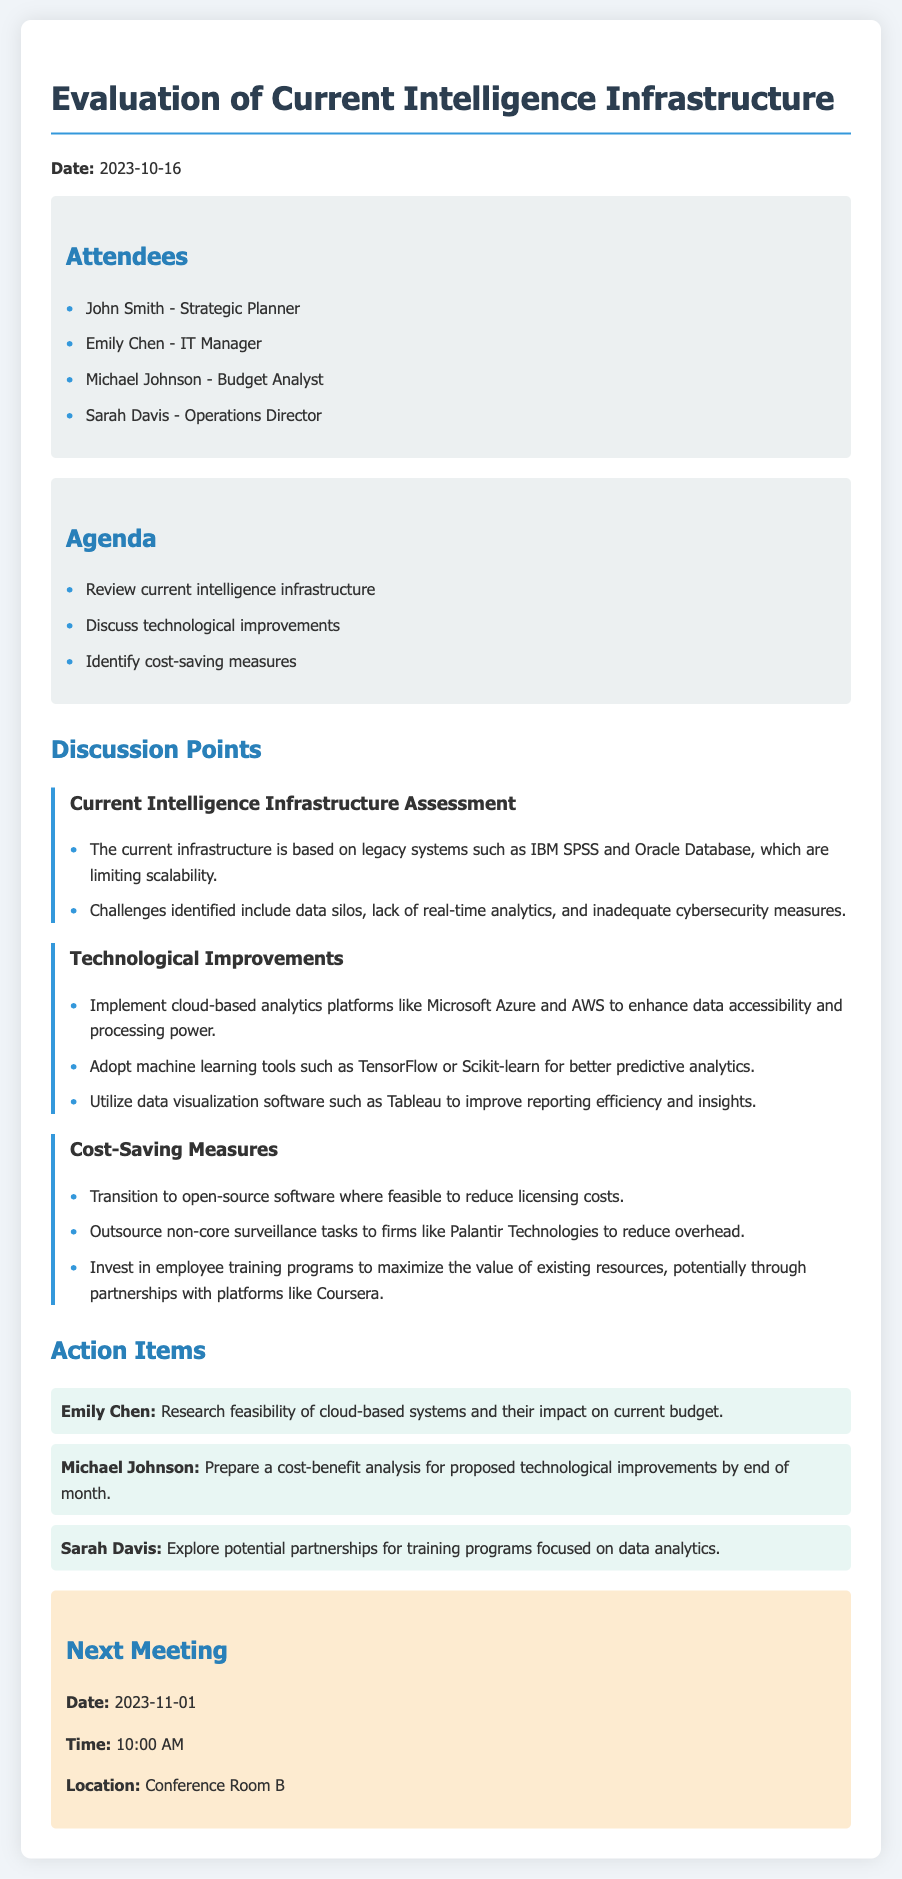What is the date of the meeting? The date of the meeting is specified at the beginning of the document as "2023-10-16".
Answer: 2023-10-16 Who is the IT Manager? The IT Manager is listed among the attendees of the meeting.
Answer: Emily Chen What is the agenda item related to technological improvements? The agenda includes discussing technological improvements as one of its points.
Answer: Discuss technological improvements What software is suggested for data visualization? The document mentions specific software that can be utilized for data visualization.
Answer: Tableau What is one of the identified challenges with the current infrastructure? Challenges are outlined in the current intelligence infrastructure assessment section of the document.
Answer: Data silos What is the action item assigned to Michael Johnson? The action items include tasks assigned to different attendees, specifically referencing Michael Johnson.
Answer: Prepare a cost-benefit analysis for proposed technological improvements by end of month What is the main recommendation for cost-saving measures? The document outlines various cost-saving measures, one of which is highlighted in detail.
Answer: Transition to open-source software where feasible When is the next meeting scheduled? The next meeting details are provided towards the end of the document.
Answer: 2023-11-01 